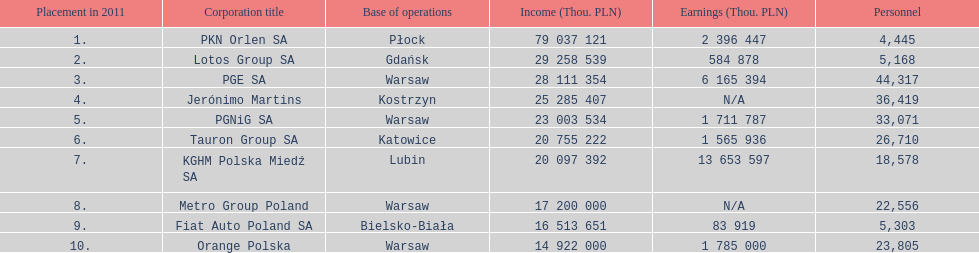What companies are listed? PKN Orlen SA, Lotos Group SA, PGE SA, Jerónimo Martins, PGNiG SA, Tauron Group SA, KGHM Polska Miedź SA, Metro Group Poland, Fiat Auto Poland SA, Orange Polska. What are the company's revenues? 79 037 121, 29 258 539, 28 111 354, 25 285 407, 23 003 534, 20 755 222, 20 097 392, 17 200 000, 16 513 651, 14 922 000. Which company has the greatest revenue? PKN Orlen SA. 